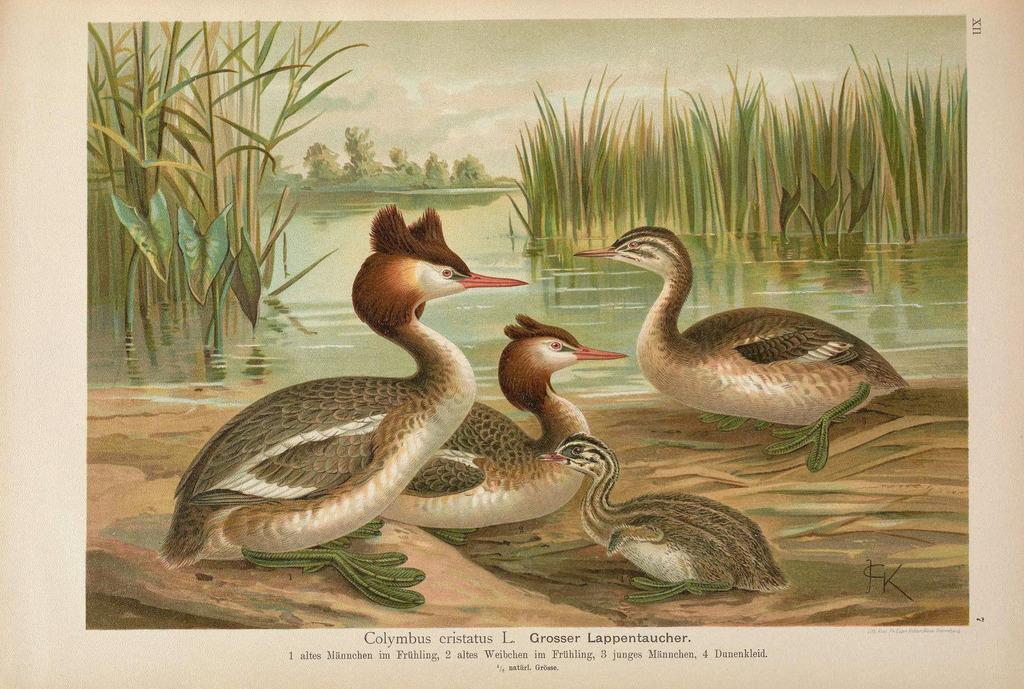How would you summarize this image in a sentence or two? In this image I can see a picture on a white paper. Under this picture there is some text. This picture consists of few birds on the ground. In the background there are few plants in the water and there are some trees. At the top I can see the sky. 